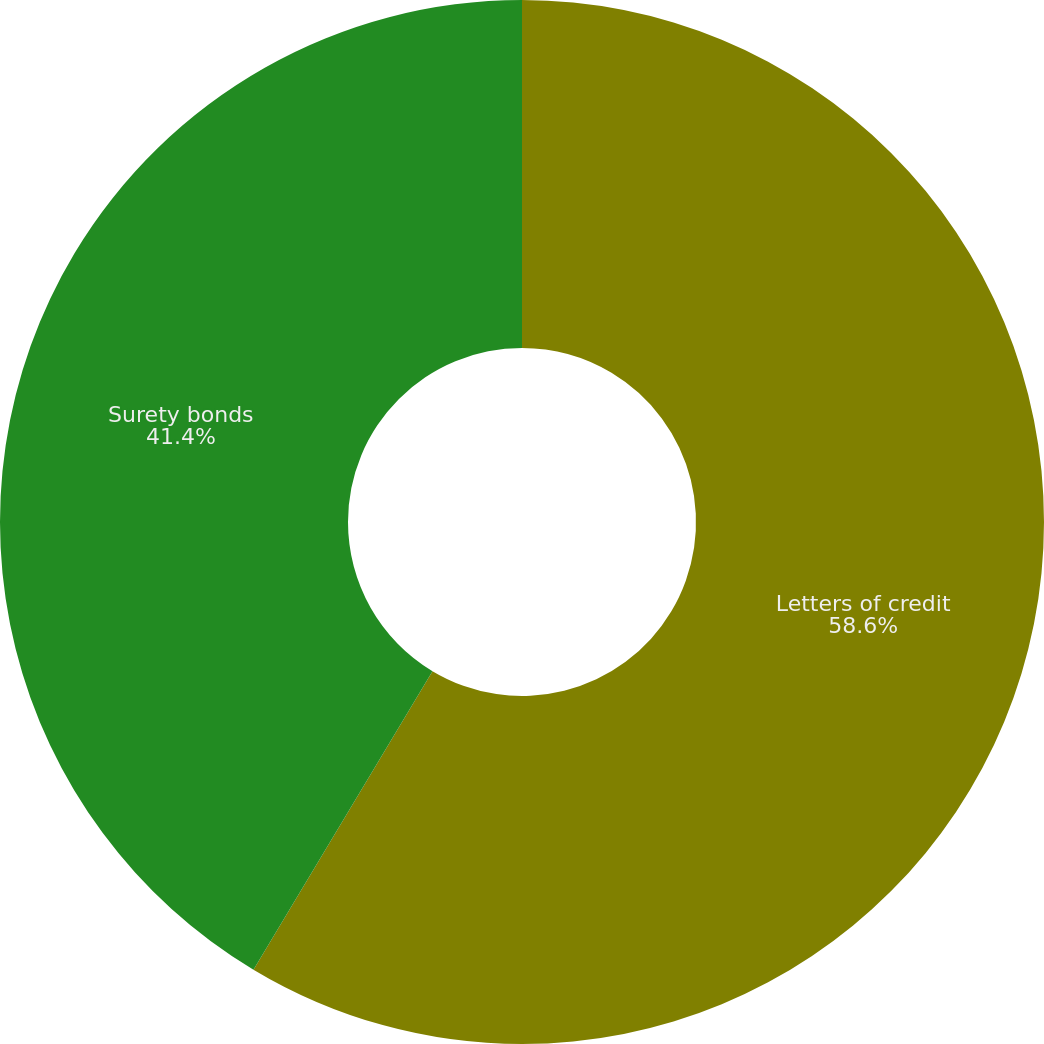Convert chart to OTSL. <chart><loc_0><loc_0><loc_500><loc_500><pie_chart><fcel>Letters of credit<fcel>Surety bonds<nl><fcel>58.6%<fcel>41.4%<nl></chart> 